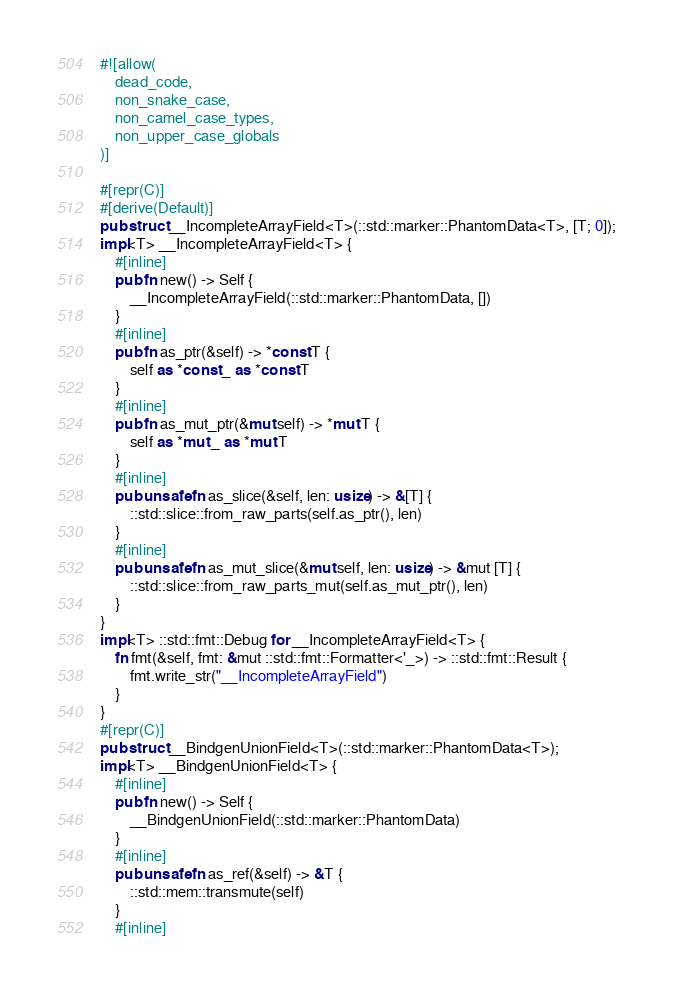<code> <loc_0><loc_0><loc_500><loc_500><_Rust_>#![allow(
    dead_code,
    non_snake_case,
    non_camel_case_types,
    non_upper_case_globals
)]

#[repr(C)]
#[derive(Default)]
pub struct __IncompleteArrayField<T>(::std::marker::PhantomData<T>, [T; 0]);
impl<T> __IncompleteArrayField<T> {
    #[inline]
    pub fn new() -> Self {
        __IncompleteArrayField(::std::marker::PhantomData, [])
    }
    #[inline]
    pub fn as_ptr(&self) -> *const T {
        self as *const _ as *const T
    }
    #[inline]
    pub fn as_mut_ptr(&mut self) -> *mut T {
        self as *mut _ as *mut T
    }
    #[inline]
    pub unsafe fn as_slice(&self, len: usize) -> &[T] {
        ::std::slice::from_raw_parts(self.as_ptr(), len)
    }
    #[inline]
    pub unsafe fn as_mut_slice(&mut self, len: usize) -> &mut [T] {
        ::std::slice::from_raw_parts_mut(self.as_mut_ptr(), len)
    }
}
impl<T> ::std::fmt::Debug for __IncompleteArrayField<T> {
    fn fmt(&self, fmt: &mut ::std::fmt::Formatter<'_>) -> ::std::fmt::Result {
        fmt.write_str("__IncompleteArrayField")
    }
}
#[repr(C)]
pub struct __BindgenUnionField<T>(::std::marker::PhantomData<T>);
impl<T> __BindgenUnionField<T> {
    #[inline]
    pub fn new() -> Self {
        __BindgenUnionField(::std::marker::PhantomData)
    }
    #[inline]
    pub unsafe fn as_ref(&self) -> &T {
        ::std::mem::transmute(self)
    }
    #[inline]</code> 